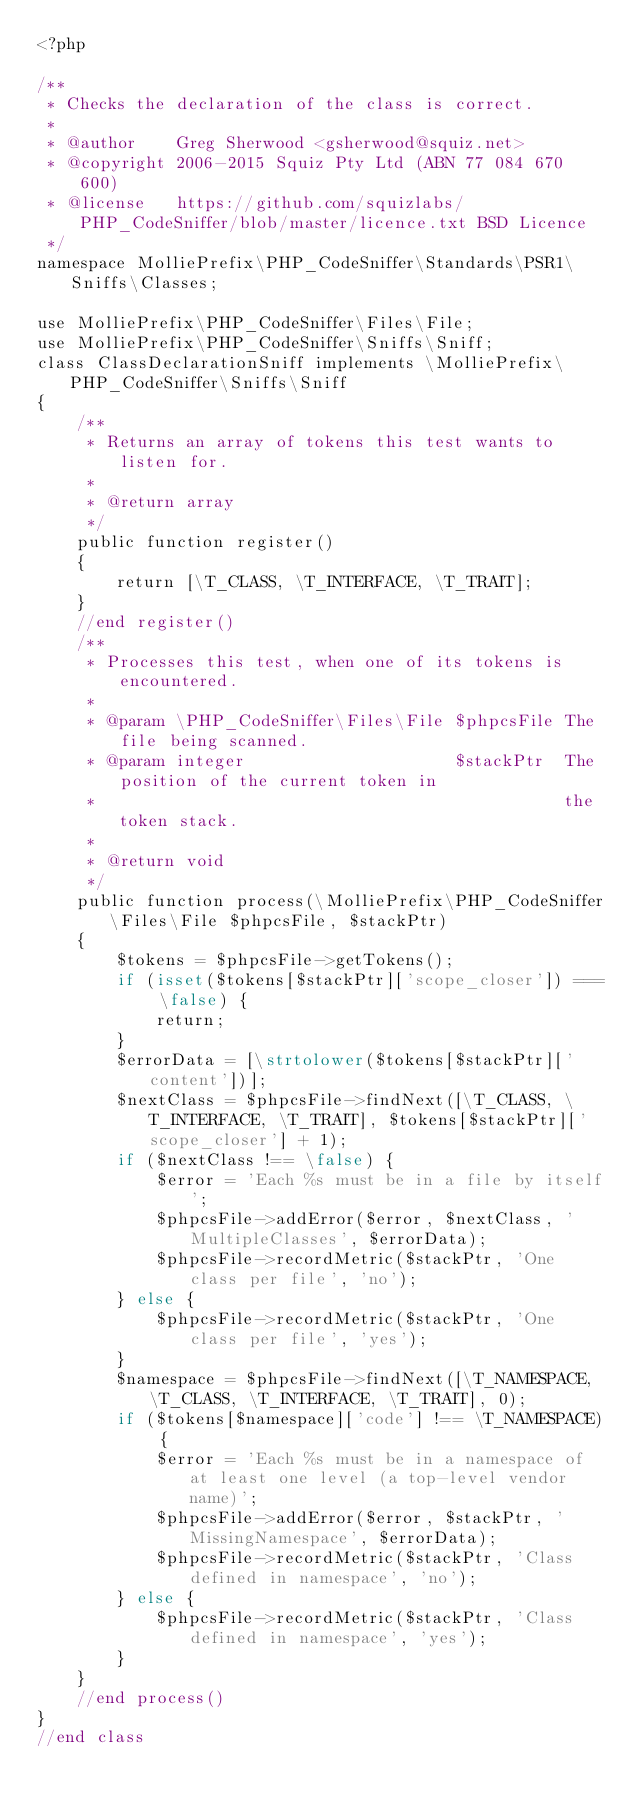<code> <loc_0><loc_0><loc_500><loc_500><_PHP_><?php

/**
 * Checks the declaration of the class is correct.
 *
 * @author    Greg Sherwood <gsherwood@squiz.net>
 * @copyright 2006-2015 Squiz Pty Ltd (ABN 77 084 670 600)
 * @license   https://github.com/squizlabs/PHP_CodeSniffer/blob/master/licence.txt BSD Licence
 */
namespace MolliePrefix\PHP_CodeSniffer\Standards\PSR1\Sniffs\Classes;

use MolliePrefix\PHP_CodeSniffer\Files\File;
use MolliePrefix\PHP_CodeSniffer\Sniffs\Sniff;
class ClassDeclarationSniff implements \MolliePrefix\PHP_CodeSniffer\Sniffs\Sniff
{
    /**
     * Returns an array of tokens this test wants to listen for.
     *
     * @return array
     */
    public function register()
    {
        return [\T_CLASS, \T_INTERFACE, \T_TRAIT];
    }
    //end register()
    /**
     * Processes this test, when one of its tokens is encountered.
     *
     * @param \PHP_CodeSniffer\Files\File $phpcsFile The file being scanned.
     * @param integer                     $stackPtr  The position of the current token in
     *                                               the token stack.
     *
     * @return void
     */
    public function process(\MolliePrefix\PHP_CodeSniffer\Files\File $phpcsFile, $stackPtr)
    {
        $tokens = $phpcsFile->getTokens();
        if (isset($tokens[$stackPtr]['scope_closer']) === \false) {
            return;
        }
        $errorData = [\strtolower($tokens[$stackPtr]['content'])];
        $nextClass = $phpcsFile->findNext([\T_CLASS, \T_INTERFACE, \T_TRAIT], $tokens[$stackPtr]['scope_closer'] + 1);
        if ($nextClass !== \false) {
            $error = 'Each %s must be in a file by itself';
            $phpcsFile->addError($error, $nextClass, 'MultipleClasses', $errorData);
            $phpcsFile->recordMetric($stackPtr, 'One class per file', 'no');
        } else {
            $phpcsFile->recordMetric($stackPtr, 'One class per file', 'yes');
        }
        $namespace = $phpcsFile->findNext([\T_NAMESPACE, \T_CLASS, \T_INTERFACE, \T_TRAIT], 0);
        if ($tokens[$namespace]['code'] !== \T_NAMESPACE) {
            $error = 'Each %s must be in a namespace of at least one level (a top-level vendor name)';
            $phpcsFile->addError($error, $stackPtr, 'MissingNamespace', $errorData);
            $phpcsFile->recordMetric($stackPtr, 'Class defined in namespace', 'no');
        } else {
            $phpcsFile->recordMetric($stackPtr, 'Class defined in namespace', 'yes');
        }
    }
    //end process()
}
//end class
</code> 